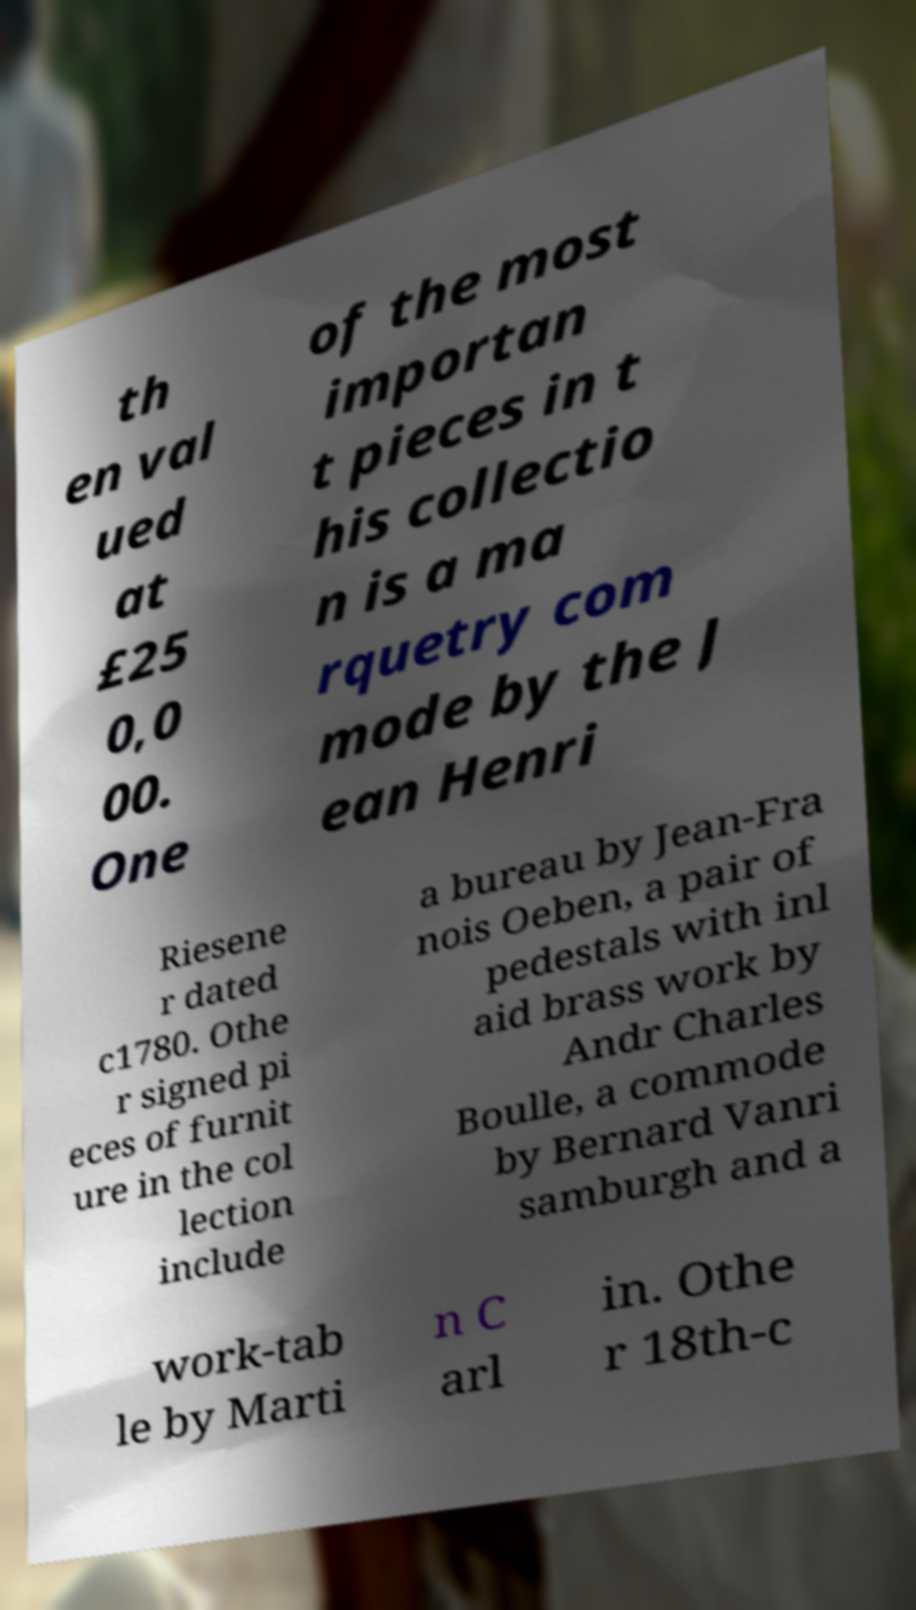Please identify and transcribe the text found in this image. th en val ued at £25 0,0 00. One of the most importan t pieces in t his collectio n is a ma rquetry com mode by the J ean Henri Riesene r dated c1780. Othe r signed pi eces of furnit ure in the col lection include a bureau by Jean-Fra nois Oeben, a pair of pedestals with inl aid brass work by Andr Charles Boulle, a commode by Bernard Vanri samburgh and a work-tab le by Marti n C arl in. Othe r 18th-c 